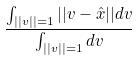Convert formula to latex. <formula><loc_0><loc_0><loc_500><loc_500>\frac { \int _ { | | v | | = 1 } | | v - \hat { x } | | d v } { \int _ { | | v | | = 1 } d v }</formula> 